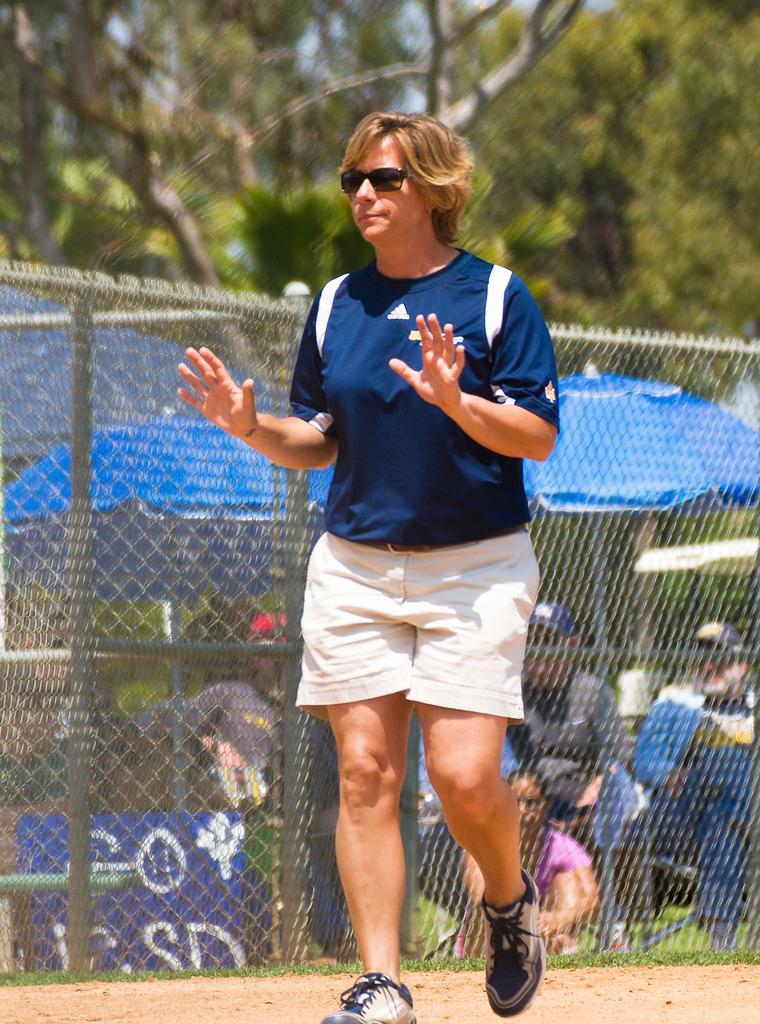Describe this image in one or two sentences. There is one woman present in the middle of this image. We can see a fence, a group of people, umbrellas and trees in the background. 